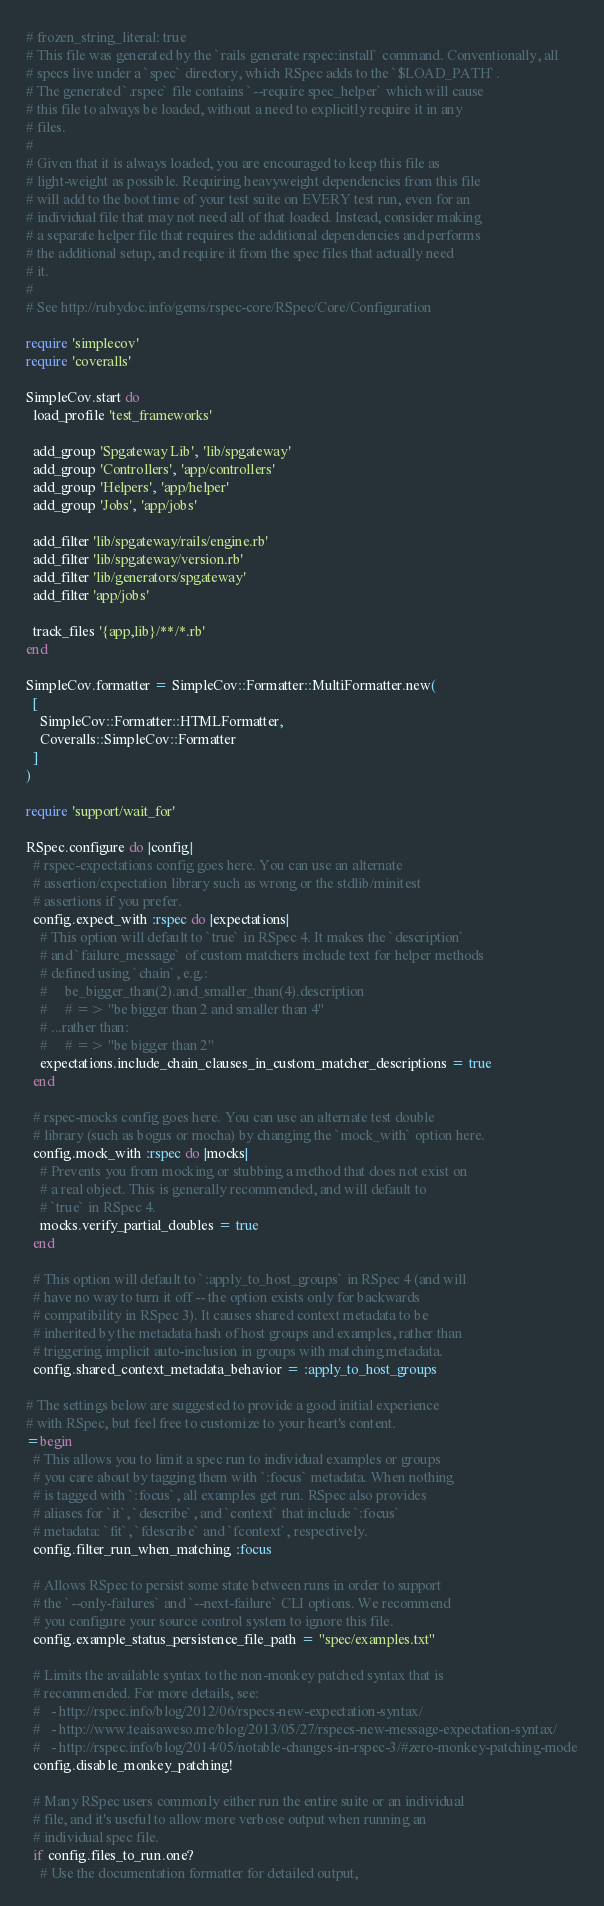Convert code to text. <code><loc_0><loc_0><loc_500><loc_500><_Ruby_># frozen_string_literal: true
# This file was generated by the `rails generate rspec:install` command. Conventionally, all
# specs live under a `spec` directory, which RSpec adds to the `$LOAD_PATH`.
# The generated `.rspec` file contains `--require spec_helper` which will cause
# this file to always be loaded, without a need to explicitly require it in any
# files.
#
# Given that it is always loaded, you are encouraged to keep this file as
# light-weight as possible. Requiring heavyweight dependencies from this file
# will add to the boot time of your test suite on EVERY test run, even for an
# individual file that may not need all of that loaded. Instead, consider making
# a separate helper file that requires the additional dependencies and performs
# the additional setup, and require it from the spec files that actually need
# it.
#
# See http://rubydoc.info/gems/rspec-core/RSpec/Core/Configuration

require 'simplecov'
require 'coveralls'

SimpleCov.start do
  load_profile 'test_frameworks'

  add_group 'Spgateway Lib', 'lib/spgateway'
  add_group 'Controllers', 'app/controllers'
  add_group 'Helpers', 'app/helper'
  add_group 'Jobs', 'app/jobs'

  add_filter 'lib/spgateway/rails/engine.rb'
  add_filter 'lib/spgateway/version.rb'
  add_filter 'lib/generators/spgateway'
  add_filter 'app/jobs'

  track_files '{app,lib}/**/*.rb'
end

SimpleCov.formatter = SimpleCov::Formatter::MultiFormatter.new(
  [
    SimpleCov::Formatter::HTMLFormatter,
    Coveralls::SimpleCov::Formatter
  ]
)

require 'support/wait_for'

RSpec.configure do |config|
  # rspec-expectations config goes here. You can use an alternate
  # assertion/expectation library such as wrong or the stdlib/minitest
  # assertions if you prefer.
  config.expect_with :rspec do |expectations|
    # This option will default to `true` in RSpec 4. It makes the `description`
    # and `failure_message` of custom matchers include text for helper methods
    # defined using `chain`, e.g.:
    #     be_bigger_than(2).and_smaller_than(4).description
    #     # => "be bigger than 2 and smaller than 4"
    # ...rather than:
    #     # => "be bigger than 2"
    expectations.include_chain_clauses_in_custom_matcher_descriptions = true
  end

  # rspec-mocks config goes here. You can use an alternate test double
  # library (such as bogus or mocha) by changing the `mock_with` option here.
  config.mock_with :rspec do |mocks|
    # Prevents you from mocking or stubbing a method that does not exist on
    # a real object. This is generally recommended, and will default to
    # `true` in RSpec 4.
    mocks.verify_partial_doubles = true
  end

  # This option will default to `:apply_to_host_groups` in RSpec 4 (and will
  # have no way to turn it off -- the option exists only for backwards
  # compatibility in RSpec 3). It causes shared context metadata to be
  # inherited by the metadata hash of host groups and examples, rather than
  # triggering implicit auto-inclusion in groups with matching metadata.
  config.shared_context_metadata_behavior = :apply_to_host_groups

# The settings below are suggested to provide a good initial experience
# with RSpec, but feel free to customize to your heart's content.
=begin
  # This allows you to limit a spec run to individual examples or groups
  # you care about by tagging them with `:focus` metadata. When nothing
  # is tagged with `:focus`, all examples get run. RSpec also provides
  # aliases for `it`, `describe`, and `context` that include `:focus`
  # metadata: `fit`, `fdescribe` and `fcontext`, respectively.
  config.filter_run_when_matching :focus

  # Allows RSpec to persist some state between runs in order to support
  # the `--only-failures` and `--next-failure` CLI options. We recommend
  # you configure your source control system to ignore this file.
  config.example_status_persistence_file_path = "spec/examples.txt"

  # Limits the available syntax to the non-monkey patched syntax that is
  # recommended. For more details, see:
  #   - http://rspec.info/blog/2012/06/rspecs-new-expectation-syntax/
  #   - http://www.teaisaweso.me/blog/2013/05/27/rspecs-new-message-expectation-syntax/
  #   - http://rspec.info/blog/2014/05/notable-changes-in-rspec-3/#zero-monkey-patching-mode
  config.disable_monkey_patching!

  # Many RSpec users commonly either run the entire suite or an individual
  # file, and it's useful to allow more verbose output when running an
  # individual spec file.
  if config.files_to_run.one?
    # Use the documentation formatter for detailed output,</code> 